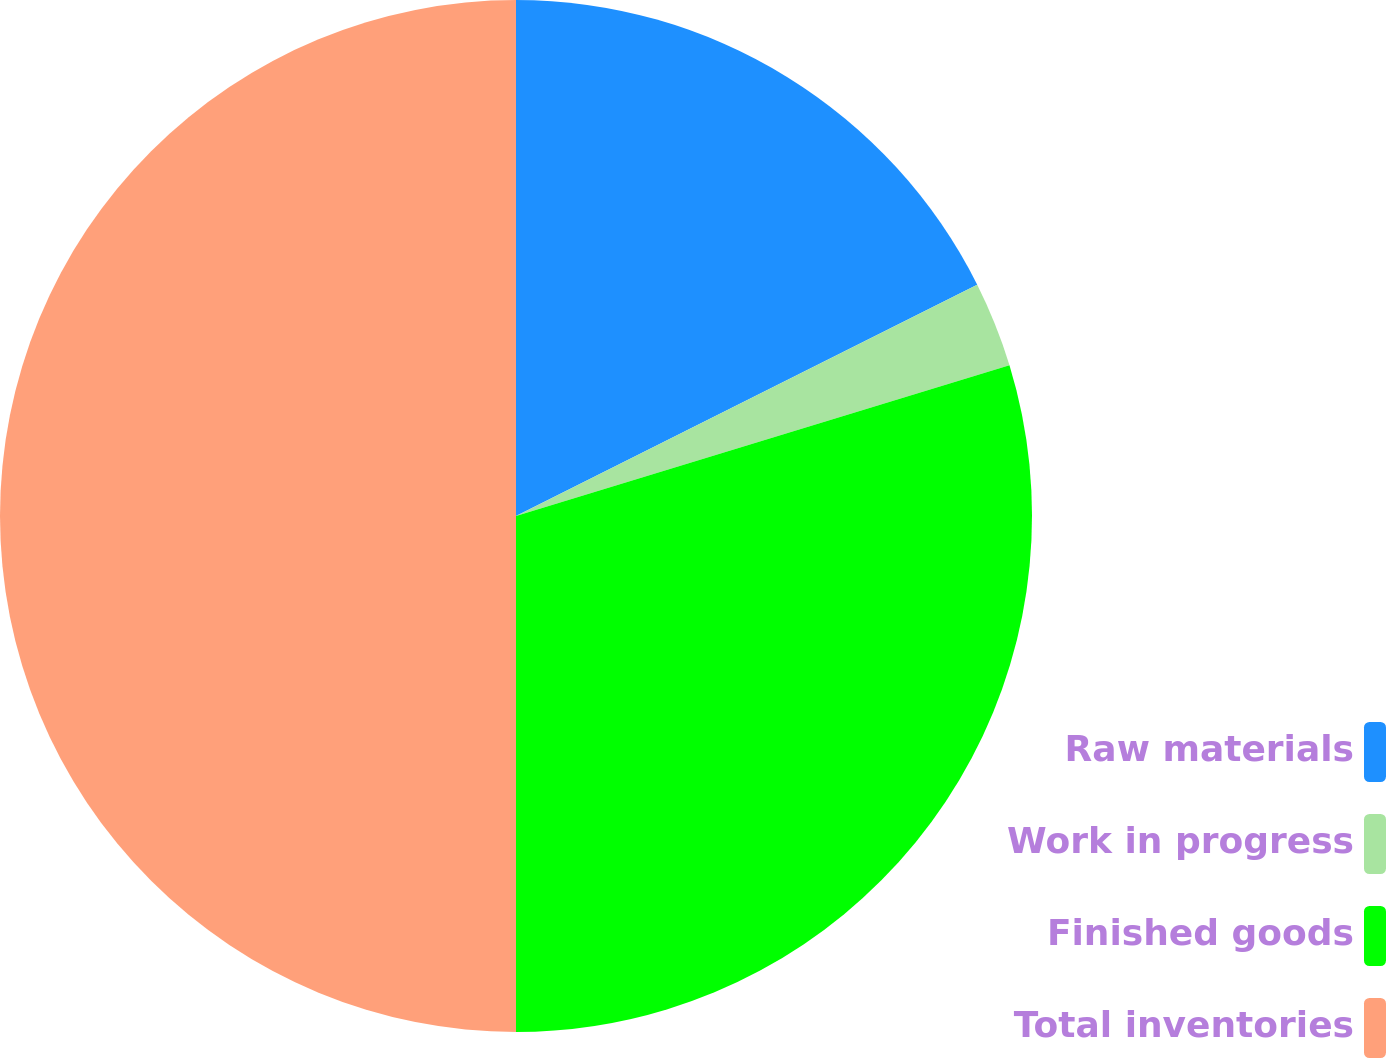Convert chart. <chart><loc_0><loc_0><loc_500><loc_500><pie_chart><fcel>Raw materials<fcel>Work in progress<fcel>Finished goods<fcel>Total inventories<nl><fcel>17.6%<fcel>2.68%<fcel>29.72%<fcel>50.0%<nl></chart> 